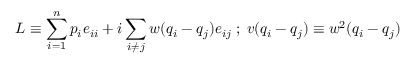<formula> <loc_0><loc_0><loc_500><loc_500>L \equiv \sum _ { i = 1 } ^ { n } p _ { i } e _ { i i } + i \sum _ { i \neq j } w ( q _ { i } - q _ { j } ) e _ { i j } \, ; \, v ( q _ { i } - q _ { j } ) \equiv w ^ { 2 } ( q _ { i } - q _ { j } )</formula> 